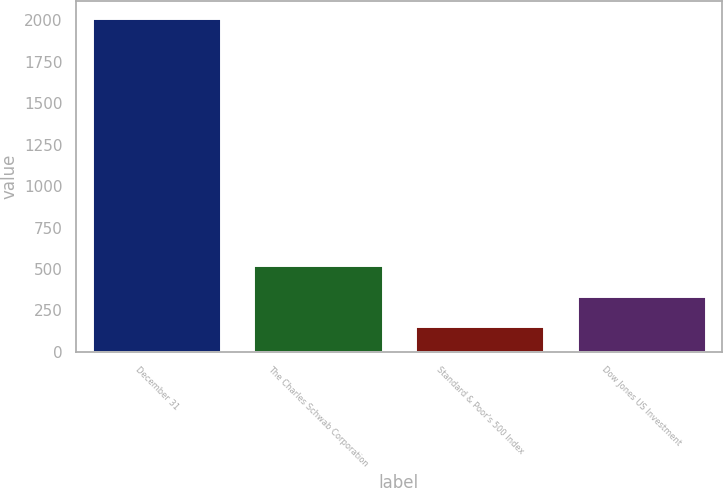Convert chart. <chart><loc_0><loc_0><loc_500><loc_500><bar_chart><fcel>December 31<fcel>The Charles Schwab Corporation<fcel>Standard & Poor's 500 Index<fcel>Dow Jones US Investment<nl><fcel>2015<fcel>525.4<fcel>153<fcel>339.2<nl></chart> 